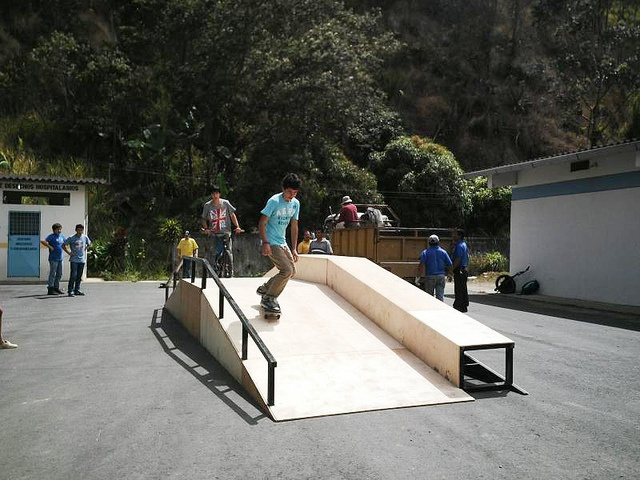Describe the objects in this image and their specific colors. I can see truck in black, maroon, and gray tones, people in black, gray, teal, and maroon tones, people in black, gray, darkgray, and maroon tones, people in black, navy, lightgray, and gray tones, and people in black, navy, gray, and darkgray tones in this image. 